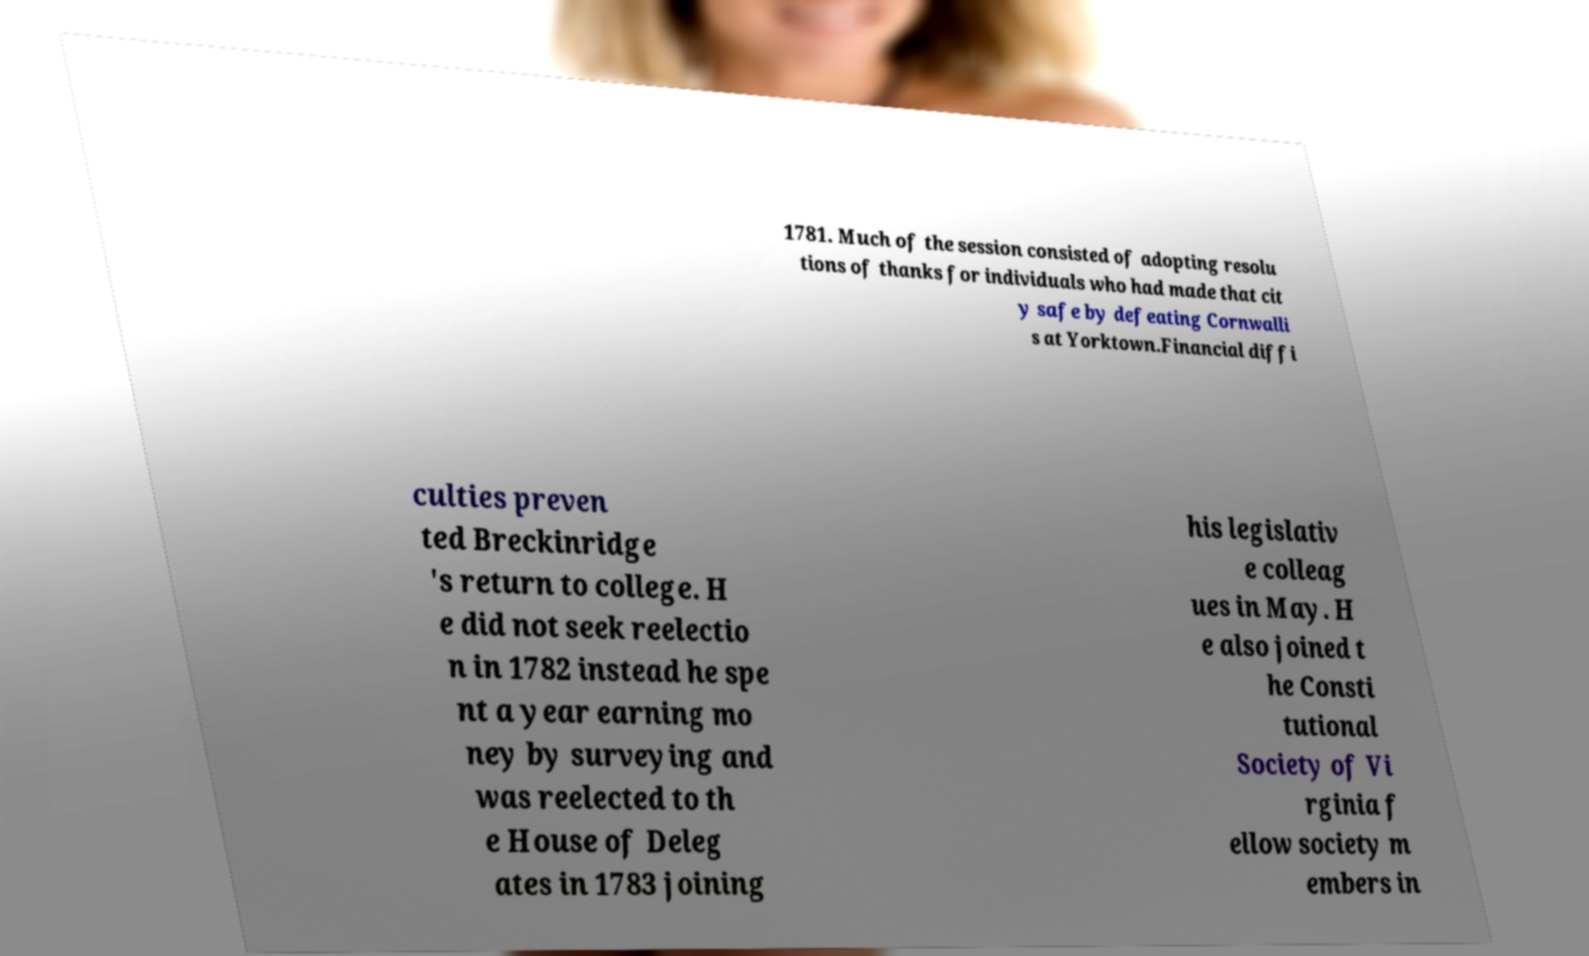Could you assist in decoding the text presented in this image and type it out clearly? 1781. Much of the session consisted of adopting resolu tions of thanks for individuals who had made that cit y safe by defeating Cornwalli s at Yorktown.Financial diffi culties preven ted Breckinridge 's return to college. H e did not seek reelectio n in 1782 instead he spe nt a year earning mo ney by surveying and was reelected to th e House of Deleg ates in 1783 joining his legislativ e colleag ues in May. H e also joined t he Consti tutional Society of Vi rginia f ellow society m embers in 